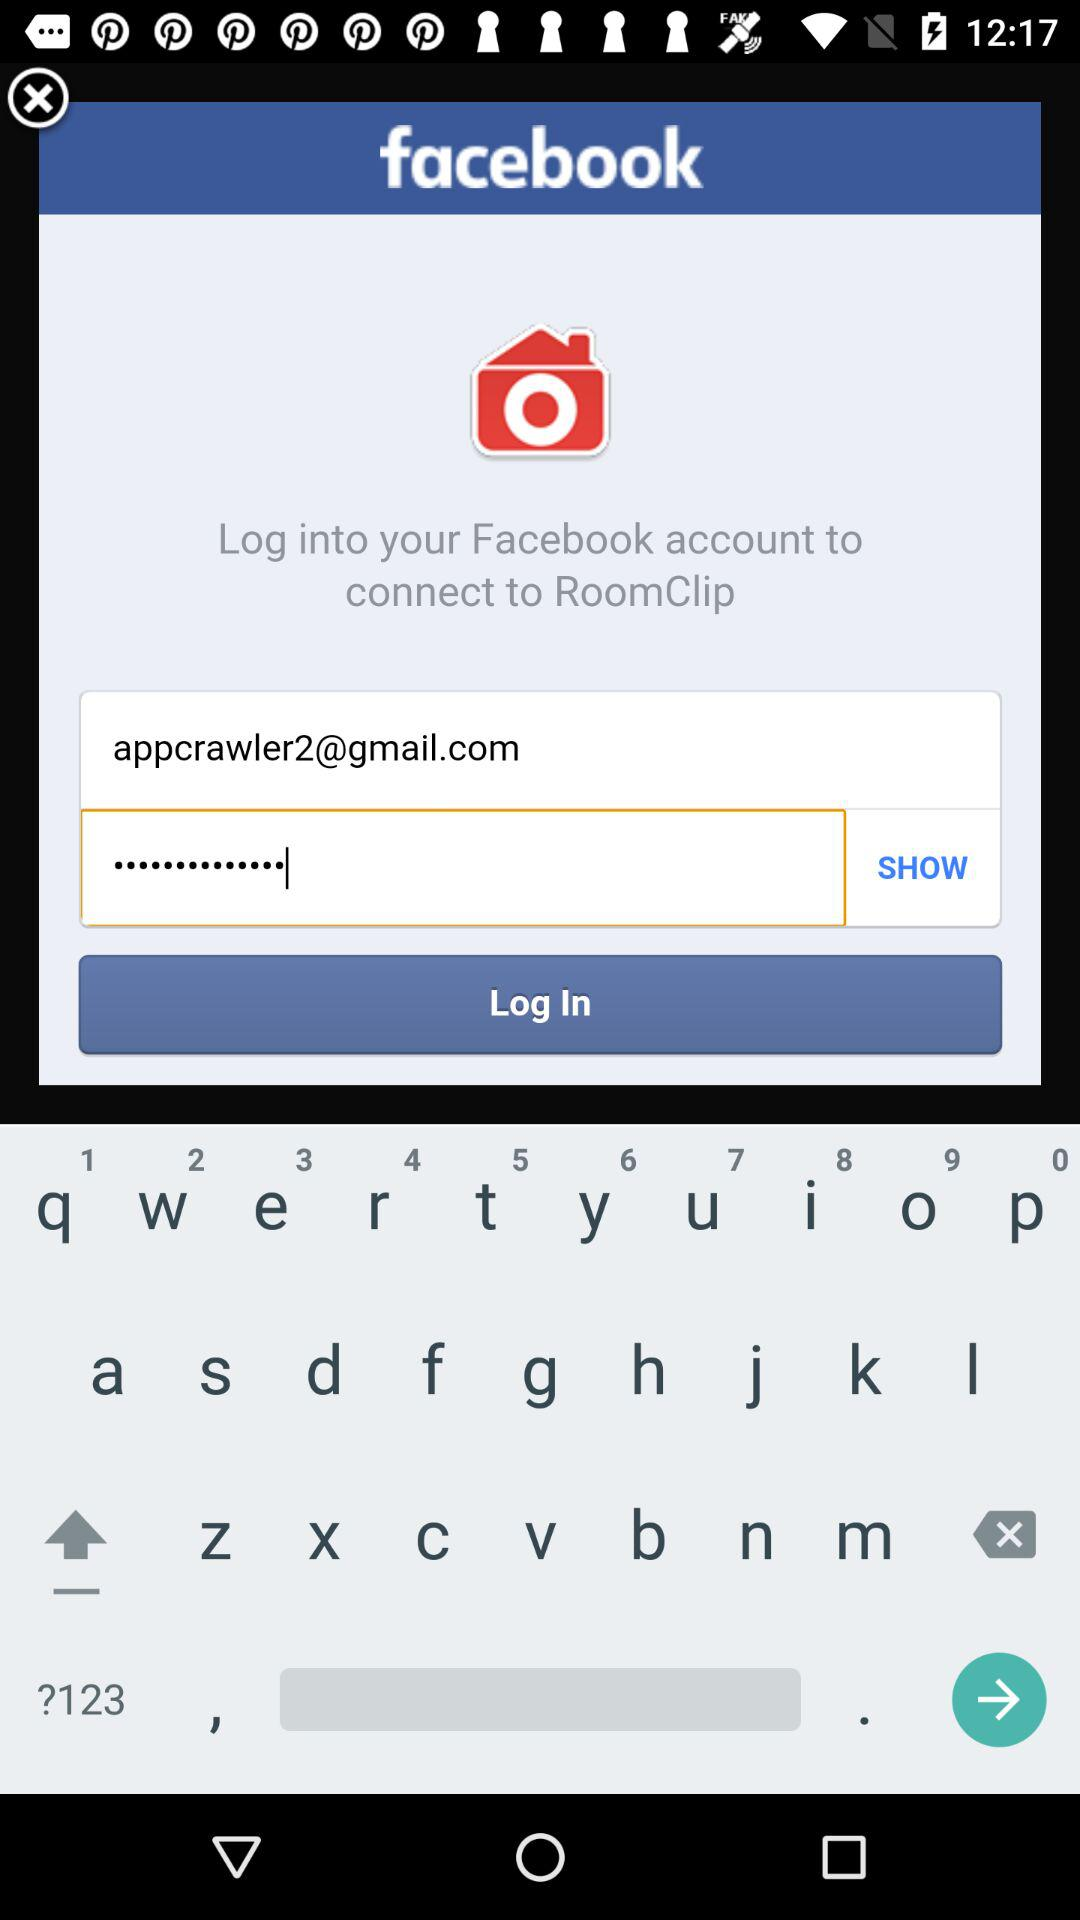What are the requirements for the password?
When the provided information is insufficient, respond with <no answer>. <no answer> 